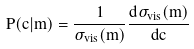Convert formula to latex. <formula><loc_0><loc_0><loc_500><loc_500>P ( c | m ) = \frac { 1 } { \sigma _ { v i s } ( m ) } \frac { d \sigma _ { v i s } ( m ) } { d c }</formula> 